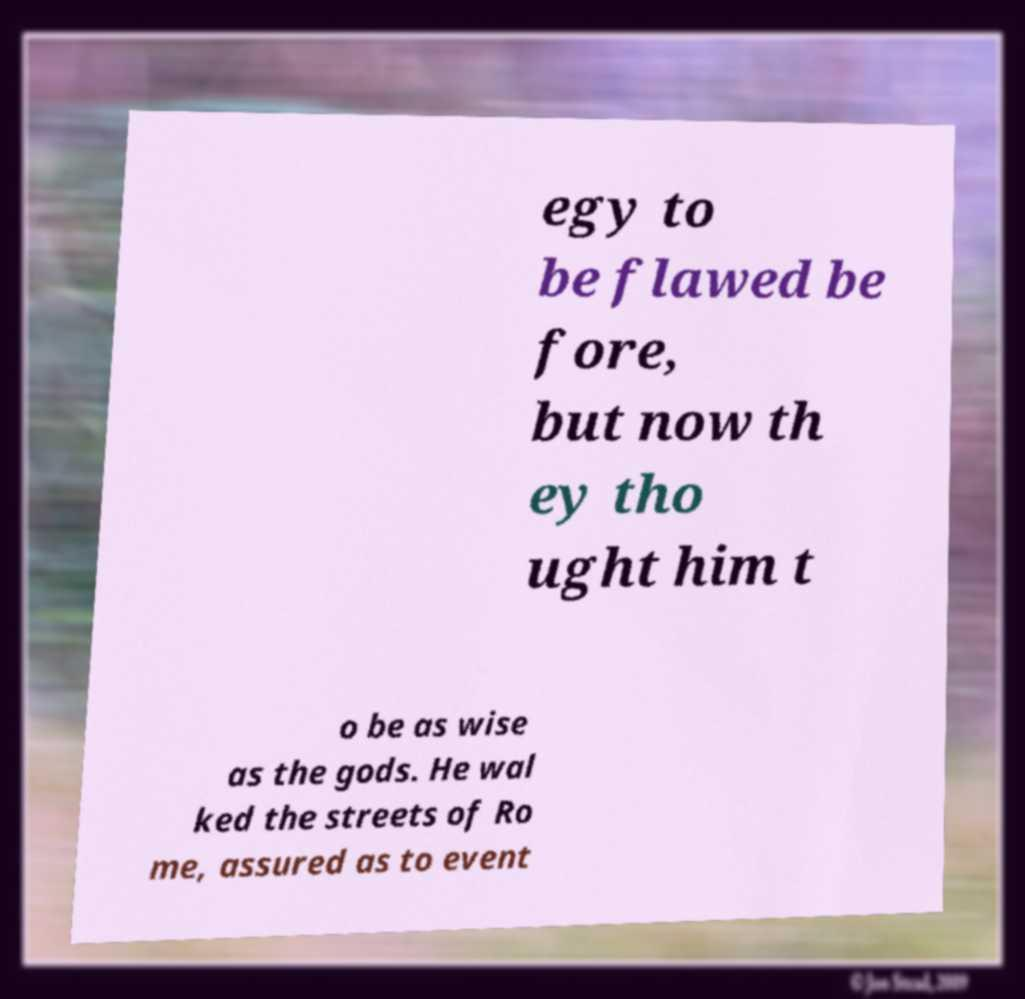Could you assist in decoding the text presented in this image and type it out clearly? egy to be flawed be fore, but now th ey tho ught him t o be as wise as the gods. He wal ked the streets of Ro me, assured as to event 